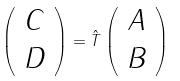<formula> <loc_0><loc_0><loc_500><loc_500>\left ( \begin{array} { c } C \\ D \end{array} \right ) = \hat { T } \left ( \begin{array} { c } A \\ B \end{array} \right )</formula> 